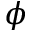Convert formula to latex. <formula><loc_0><loc_0><loc_500><loc_500>\phi</formula> 